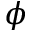Convert formula to latex. <formula><loc_0><loc_0><loc_500><loc_500>\phi</formula> 